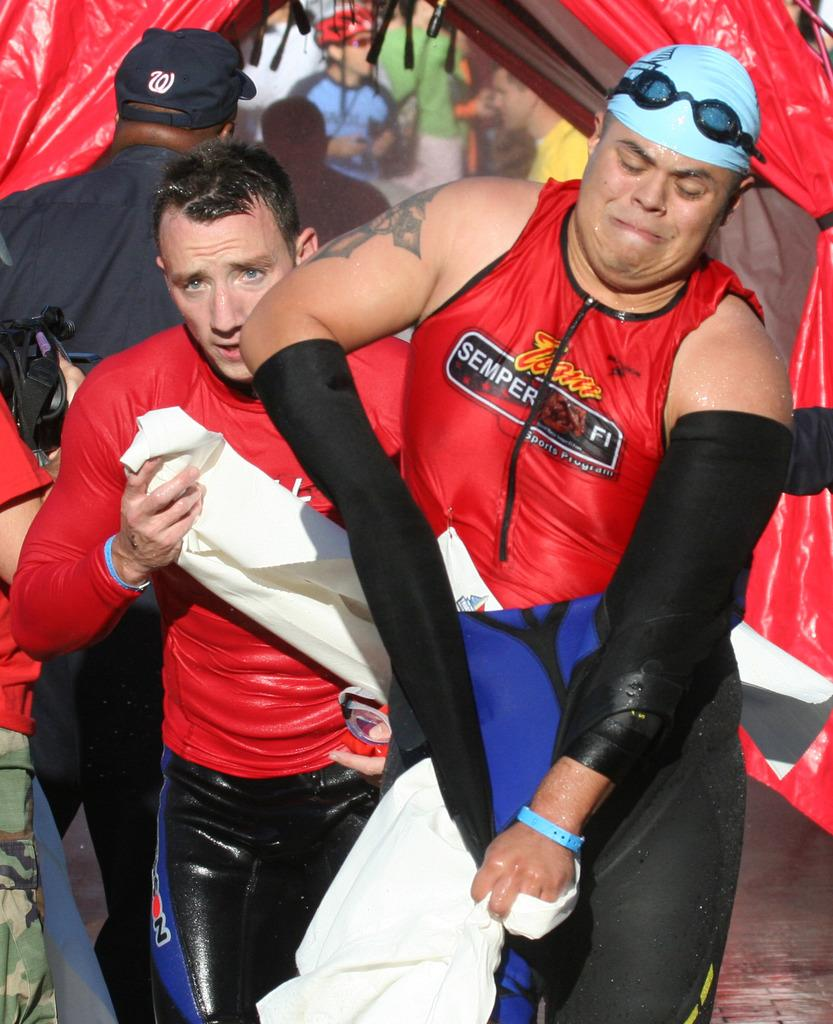<image>
Write a terse but informative summary of the picture. 2 Men in a competition together with red shirts saying Team Semper FI. 